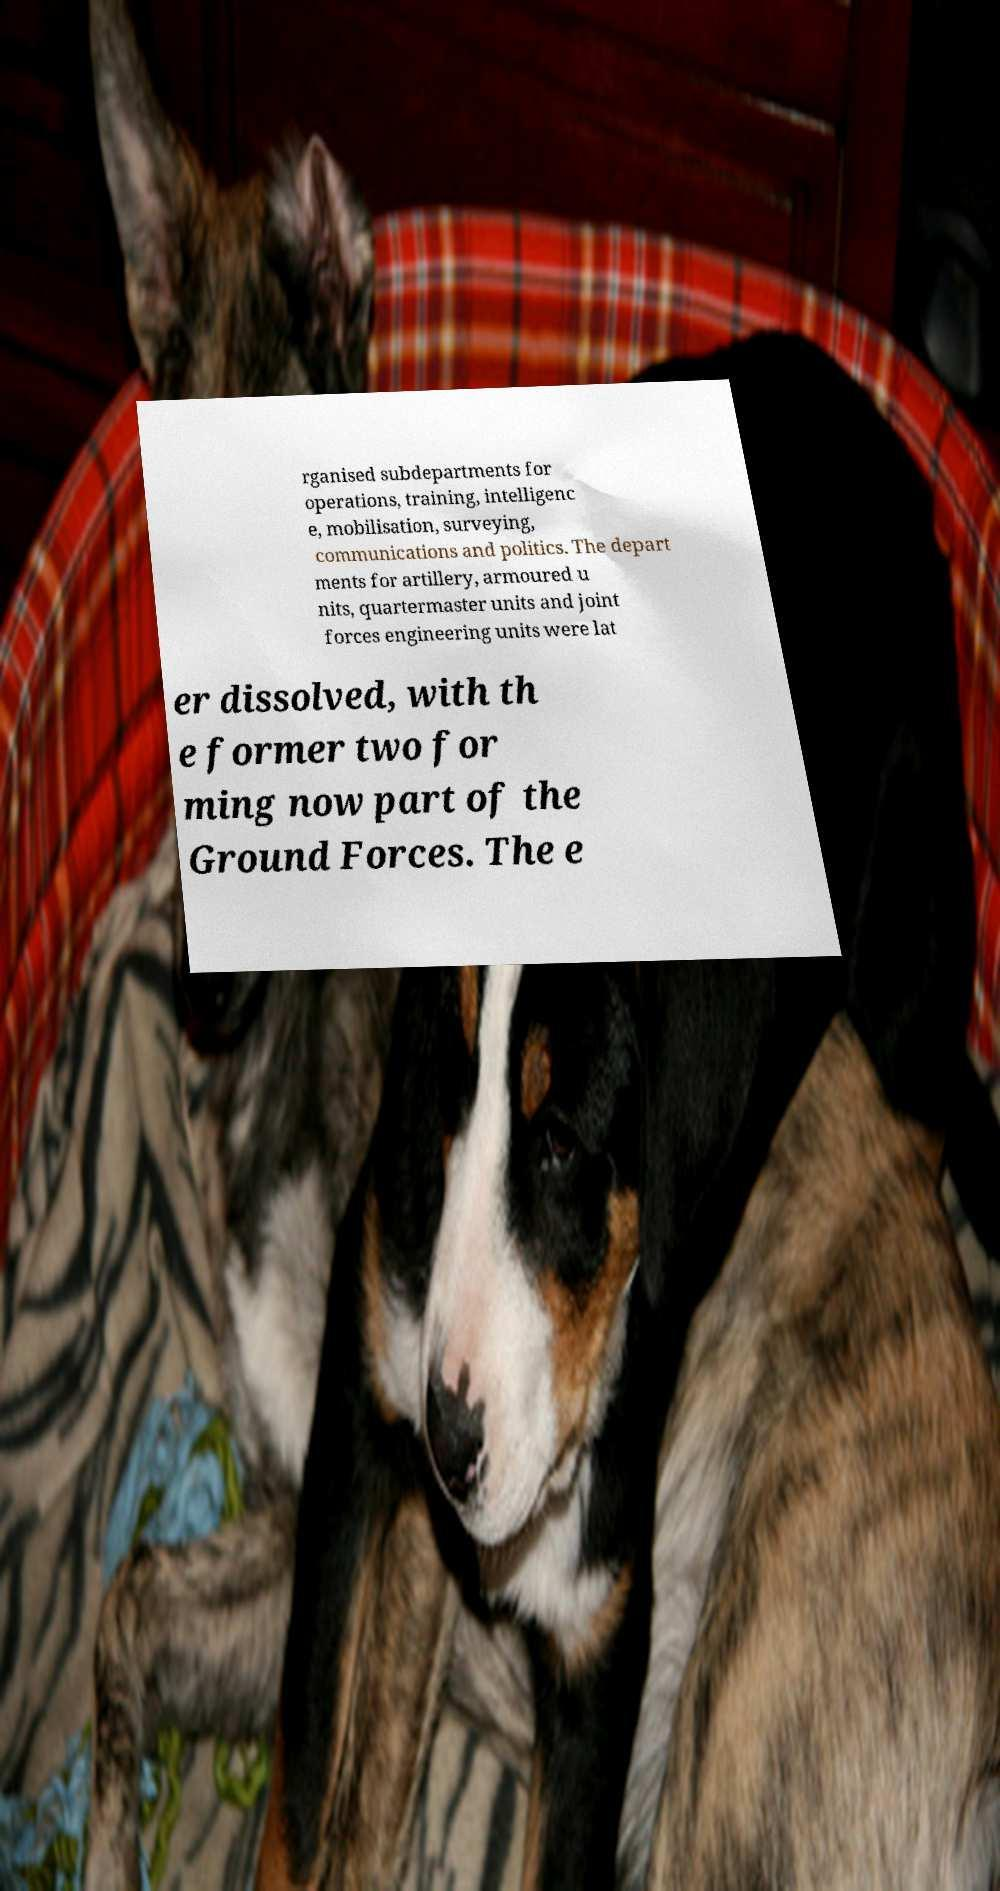What messages or text are displayed in this image? I need them in a readable, typed format. rganised subdepartments for operations, training, intelligenc e, mobilisation, surveying, communications and politics. The depart ments for artillery, armoured u nits, quartermaster units and joint forces engineering units were lat er dissolved, with th e former two for ming now part of the Ground Forces. The e 